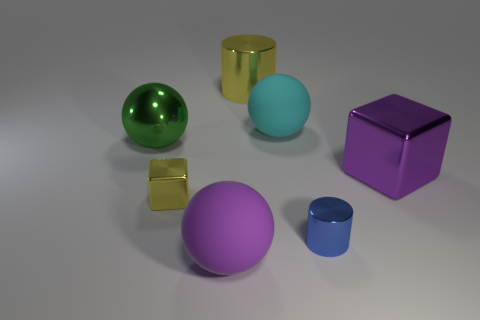Describe the arrangement of colors in the image. The image showcases a harmonious and vibrant arrangement of colors with objects in green, gold, light blue, purple, and pink, creating an aesthetic and pleasing visual experience. 